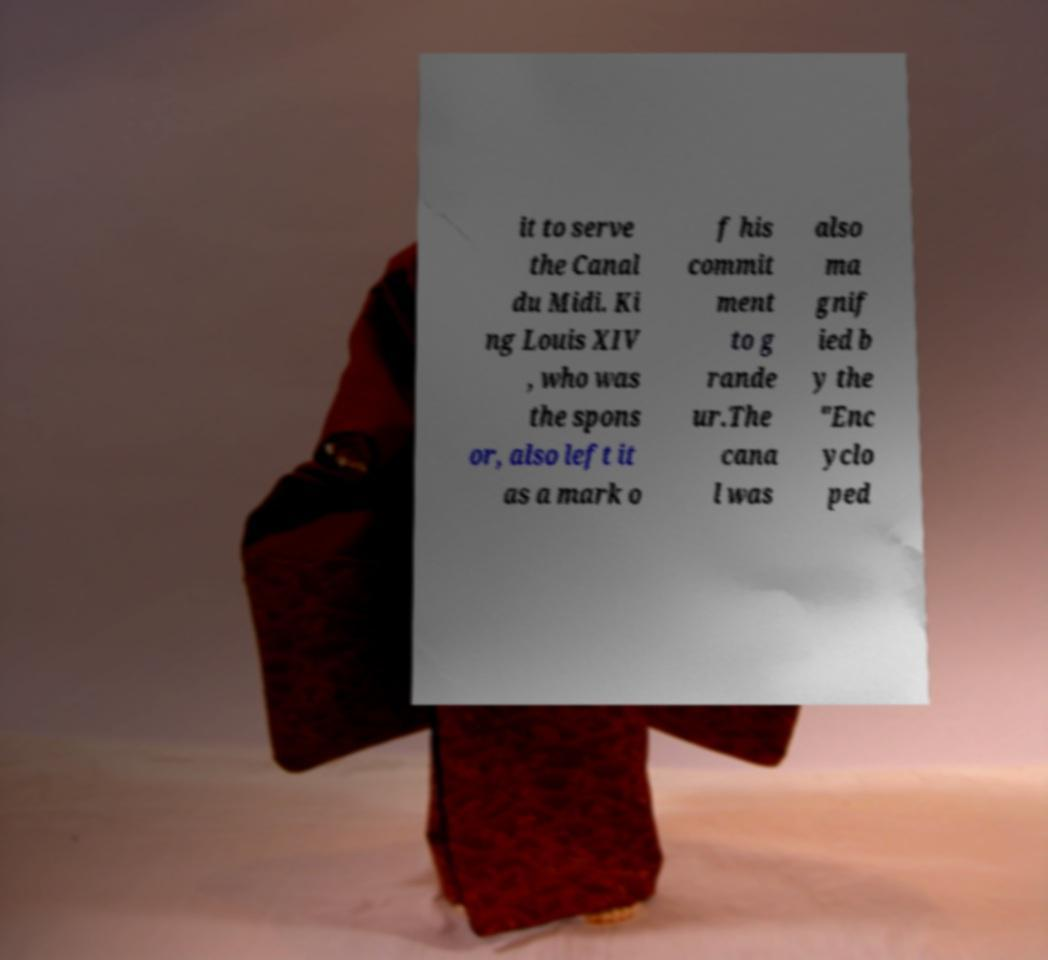I need the written content from this picture converted into text. Can you do that? it to serve the Canal du Midi. Ki ng Louis XIV , who was the spons or, also left it as a mark o f his commit ment to g rande ur.The cana l was also ma gnif ied b y the "Enc yclo ped 